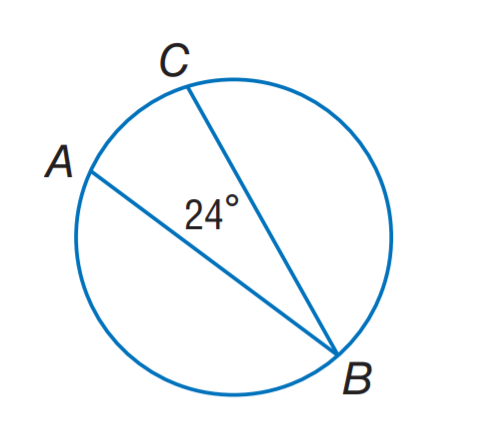Answer the mathemtical geometry problem and directly provide the correct option letter.
Question: Find m \widehat A C.
Choices: A: 12 B: 24 C: 48 D: 96 C 